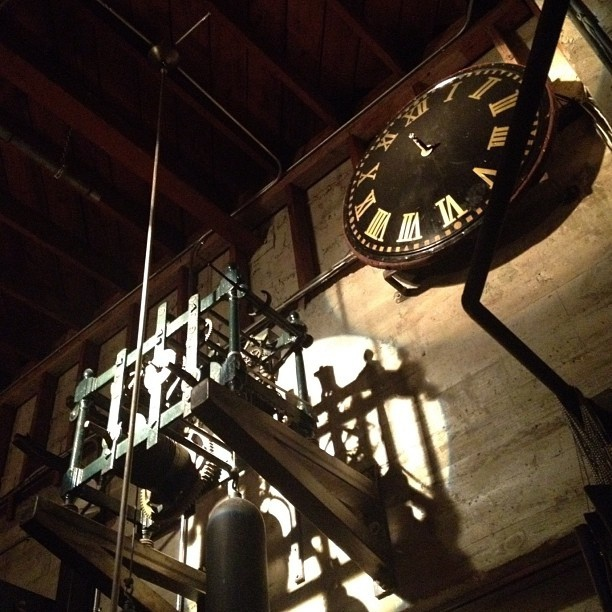Describe the objects in this image and their specific colors. I can see a clock in black, maroon, and tan tones in this image. 